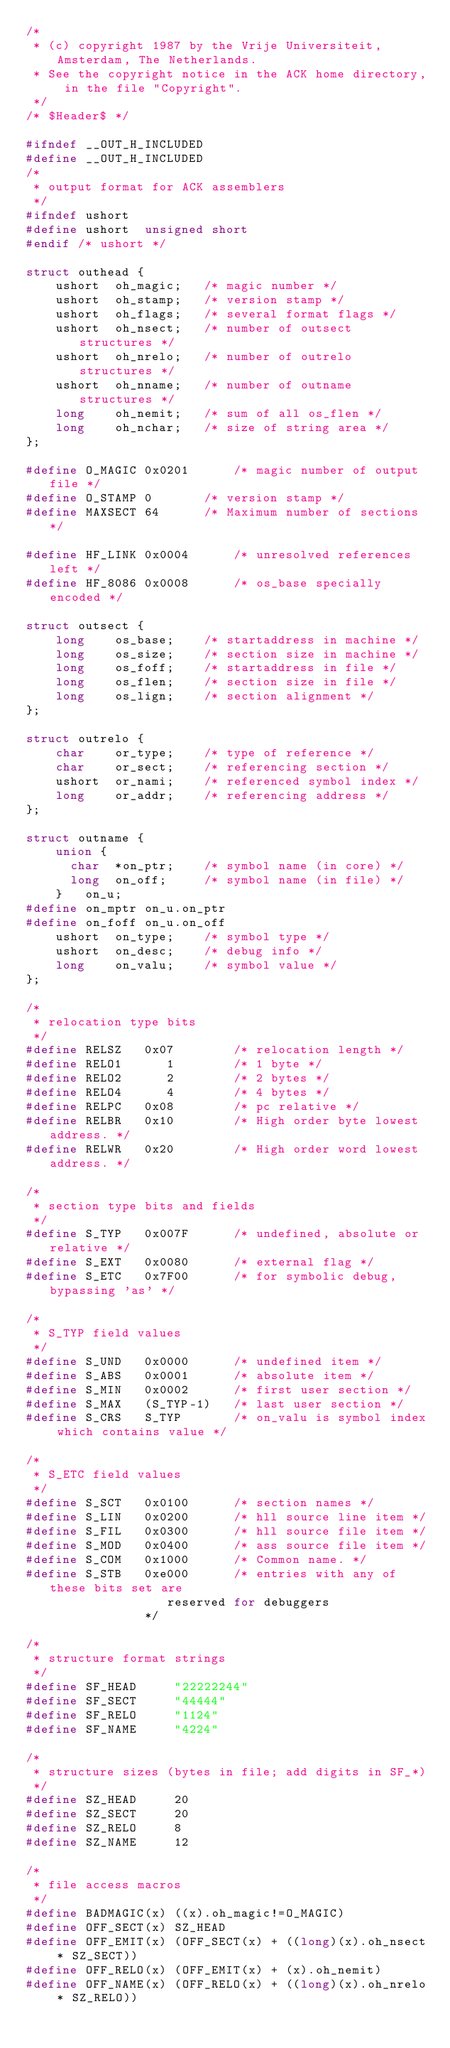Convert code to text. <code><loc_0><loc_0><loc_500><loc_500><_C_>/*
 * (c) copyright 1987 by the Vrije Universiteit, Amsterdam, The Netherlands.
 * See the copyright notice in the ACK home directory, in the file "Copyright".
 */
/* $Header$ */

#ifndef __OUT_H_INCLUDED
#define __OUT_H_INCLUDED
/*
 * output format for ACK assemblers
 */
#ifndef ushort
#define ushort	unsigned short
#endif /* ushort */

struct outhead {
	ushort 	oh_magic;	/* magic number */
	ushort 	oh_stamp;	/* version stamp */
	ushort	oh_flags;	/* several format flags */
	ushort	oh_nsect;	/* number of outsect structures */
	ushort	oh_nrelo;	/* number of outrelo structures */
	ushort	oh_nname;	/* number of outname structures */
	long	oh_nemit;	/* sum of all os_flen */
	long	oh_nchar;	/* size of string area */
};

#define O_MAGIC	0x0201		/* magic number of output file */
#define	O_STAMP	0		/* version stamp */
#define MAXSECT	64		/* Maximum number of sections */

#define	HF_LINK	0x0004		/* unresolved references left */
#define	HF_8086	0x0008		/* os_base specially encoded */

struct outsect {
	long 	os_base;	/* startaddress in machine */
	long	os_size;	/* section size in machine */
	long	os_foff;	/* startaddress in file */
	long	os_flen;	/* section size in file */
	long	os_lign;	/* section alignment */
};

struct outrelo {
	char	or_type;	/* type of reference */
	char	or_sect;	/* referencing section */
	ushort	or_nami;	/* referenced symbol index */
	long	or_addr;	/* referencing address */
};

struct outname {
	union {
	  char	*on_ptr;	/* symbol name (in core) */
	  long	on_off;		/* symbol name (in file) */
	}	on_u;
#define on_mptr	on_u.on_ptr
#define on_foff	on_u.on_off
	ushort	on_type;	/* symbol type */
	ushort	on_desc;	/* debug info */
	long	on_valu;	/* symbol value */
};

/*
 * relocation type bits
 */
#define RELSZ	0x07		/* relocation length */
#define RELO1	   1		/* 1 byte */
#define RELO2	   2		/* 2 bytes */
#define RELO4	   4		/* 4 bytes */
#define RELPC	0x08		/* pc relative */
#define RELBR	0x10		/* High order byte lowest address. */
#define RELWR	0x20		/* High order word lowest address. */

/*
 * section type bits and fields
 */
#define S_TYP	0x007F		/* undefined, absolute or relative */
#define S_EXT	0x0080		/* external flag */
#define S_ETC	0x7F00		/* for symbolic debug, bypassing 'as' */

/*
 * S_TYP field values
 */
#define S_UND	0x0000		/* undefined item */
#define S_ABS	0x0001		/* absolute item */
#define S_MIN	0x0002		/* first user section */
#define S_MAX	(S_TYP-1)	/* last user section */
#define S_CRS	S_TYP		/* on_valu is symbol index which contains value */

/*
 * S_ETC field values
 */
#define S_SCT	0x0100		/* section names */
#define S_LIN	0x0200		/* hll source line item */
#define S_FIL	0x0300		/* hll source file item */
#define S_MOD	0x0400		/* ass source file item */
#define S_COM	0x1000		/* Common name. */
#define S_STB	0xe000		/* entries with any of these bits set are
				   reserved for debuggers
				*/

/*
 * structure format strings
 */
#define SF_HEAD		"22222244"
#define SF_SECT		"44444"
#define SF_RELO		"1124"
#define SF_NAME		"4224"

/*
 * structure sizes (bytes in file; add digits in SF_*)
 */
#define SZ_HEAD		20
#define SZ_SECT		20
#define SZ_RELO		8
#define SZ_NAME		12

/*
 * file access macros
 */
#define BADMAGIC(x)	((x).oh_magic!=O_MAGIC)
#define OFF_SECT(x)	SZ_HEAD
#define OFF_EMIT(x)	(OFF_SECT(x) + ((long)(x).oh_nsect * SZ_SECT))
#define OFF_RELO(x)	(OFF_EMIT(x) + (x).oh_nemit)
#define OFF_NAME(x)	(OFF_RELO(x) + ((long)(x).oh_nrelo * SZ_RELO))</code> 